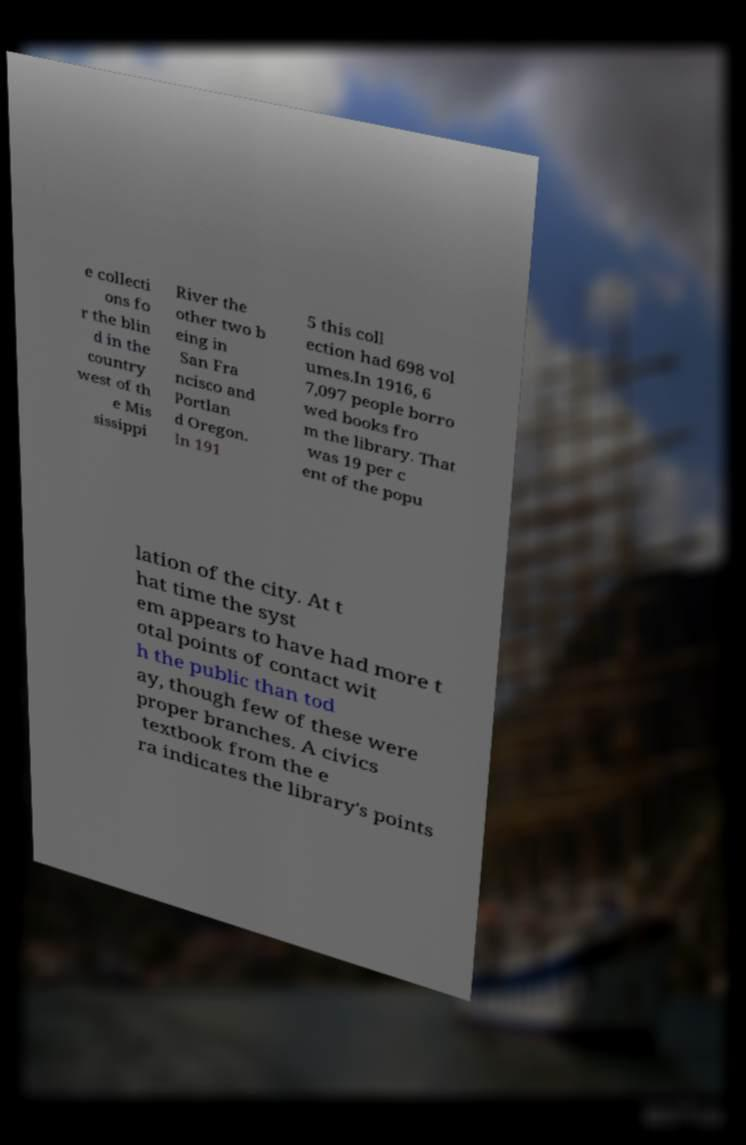Please read and relay the text visible in this image. What does it say? e collecti ons fo r the blin d in the country west of th e Mis sissippi River the other two b eing in San Fra ncisco and Portlan d Oregon. In 191 5 this coll ection had 698 vol umes.In 1916, 6 7,097 people borro wed books fro m the library. That was 19 per c ent of the popu lation of the city. At t hat time the syst em appears to have had more t otal points of contact wit h the public than tod ay, though few of these were proper branches. A civics textbook from the e ra indicates the library's points 